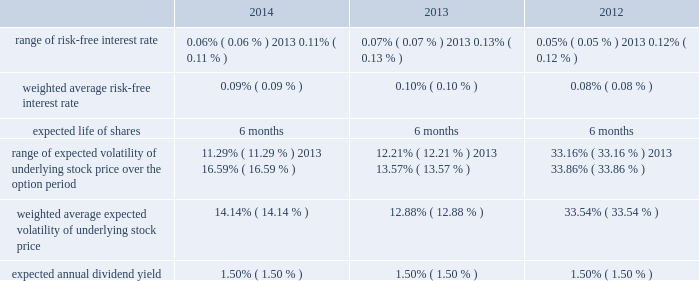American tower corporation and subsidiaries notes to consolidated financial statements six-month offering period .
The weighted average fair value per share of espp share purchase options during the year ended december 31 , 2014 , 2013 and 2012 was $ 14.83 , $ 13.42 and $ 13.64 , respectively .
At december 31 , 2014 , 3.4 million shares remain reserved for future issuance under the plan .
Key assumptions used to apply the black-scholes pricing model for shares purchased through the espp for the years ended december 31 , are as follows: .
16 .
Equity mandatory convertible preferred stock offering 2014on may 12 , 2014 , the company completed a registered public offering of 6000000 shares of its 5.25% ( 5.25 % ) mandatory convertible preferred stock , series a , par value $ 0.01 per share ( the 201cmandatory convertible preferred stock 201d ) .
The net proceeds of the offering were $ 582.9 million after deducting commissions and estimated expenses .
The company used the net proceeds from this offering to fund acquisitions , including the acquisition from richland , initially funded by indebtedness incurred under the 2013 credit facility .
Unless converted earlier , each share of the mandatory convertible preferred stock will automatically convert on may 15 , 2017 , into between 0.9174 and 1.1468 shares of common stock , depending on the applicable market value of the common stock and subject to anti-dilution adjustments .
Subject to certain restrictions , at any time prior to may 15 , 2017 , holders of the mandatory convertible preferred stock may elect to convert all or a portion of their shares into common stock at the minimum conversion rate then in effect .
Dividends on shares of mandatory convertible preferred stock are payable on a cumulative basis when , as and if declared by the company 2019s board of directors ( or an authorized committee thereof ) at an annual rate of 5.25% ( 5.25 % ) on the liquidation preference of $ 100.00 per share , on february 15 , may 15 , august 15 and november 15 of each year , commencing on august 15 , 2014 to , and including , may 15 , 2017 .
The company may pay dividends in cash or , subject to certain limitations , in shares of common stock or any combination of cash and shares of common stock .
The terms of the mandatory convertible preferred stock provide that , unless full cumulative dividends have been paid or set aside for payment on all outstanding mandatory convertible preferred stock for all prior dividend periods , no dividends may be declared or paid on common stock .
Stock repurchase program 2014in march 2011 , the board of directors approved a stock repurchase program , pursuant to which the company is authorized to purchase up to $ 1.5 billion of common stock ( 201c2011 buyback 201d ) .
In september 2013 , the company temporarily suspended repurchases in connection with its acquisition of mipt .
Under the 2011 buyback , the company is authorized to purchase shares from time to time through open market purchases or privately negotiated transactions at prevailing prices in accordance with securities laws and other legal requirements , and subject to market conditions and other factors .
To facilitate repurchases , the company .
Assuming conversion at the maximum share conversion rate , how many common shares would result from a conversion of the mandatory convertible preferred stock , series a? 
Computations: (6000000 * 1.1468)
Answer: 6880800.0. 